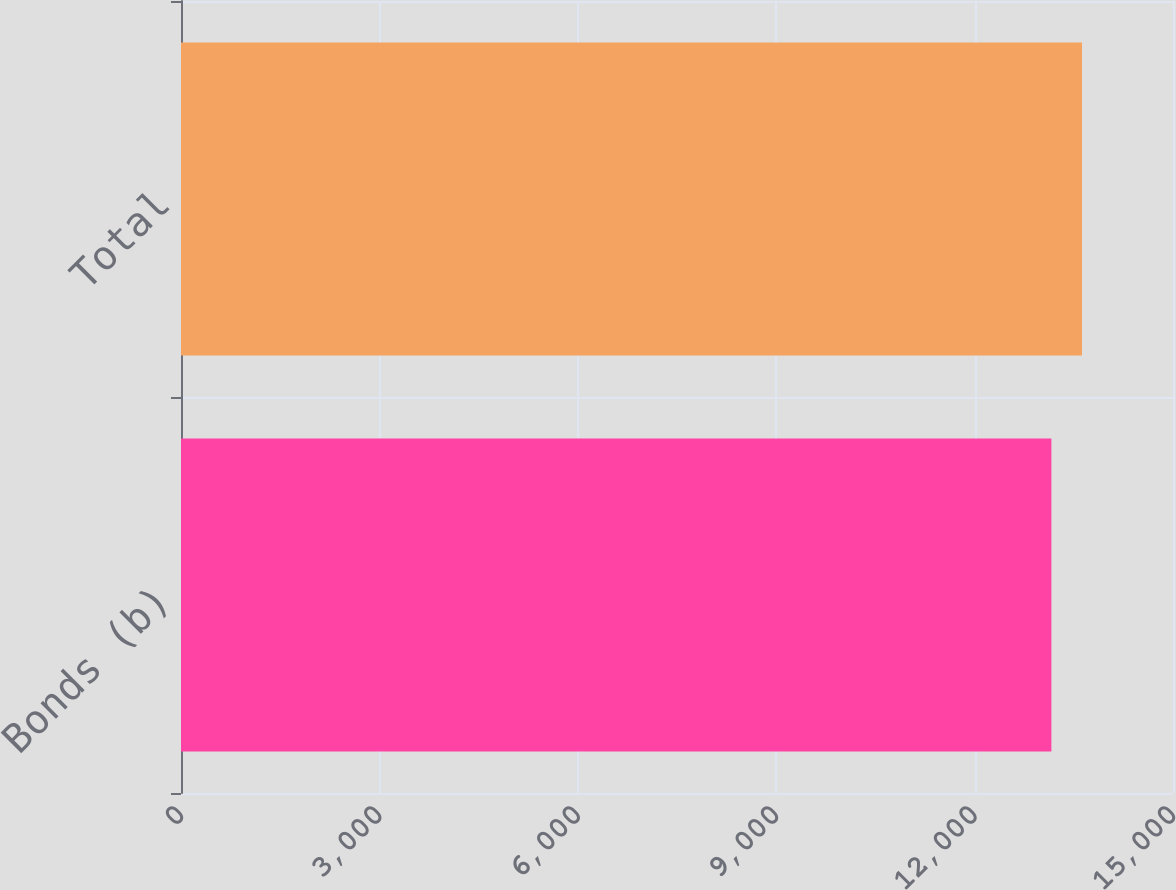Convert chart. <chart><loc_0><loc_0><loc_500><loc_500><bar_chart><fcel>Bonds (b)<fcel>Total<nl><fcel>13161<fcel>13624<nl></chart> 